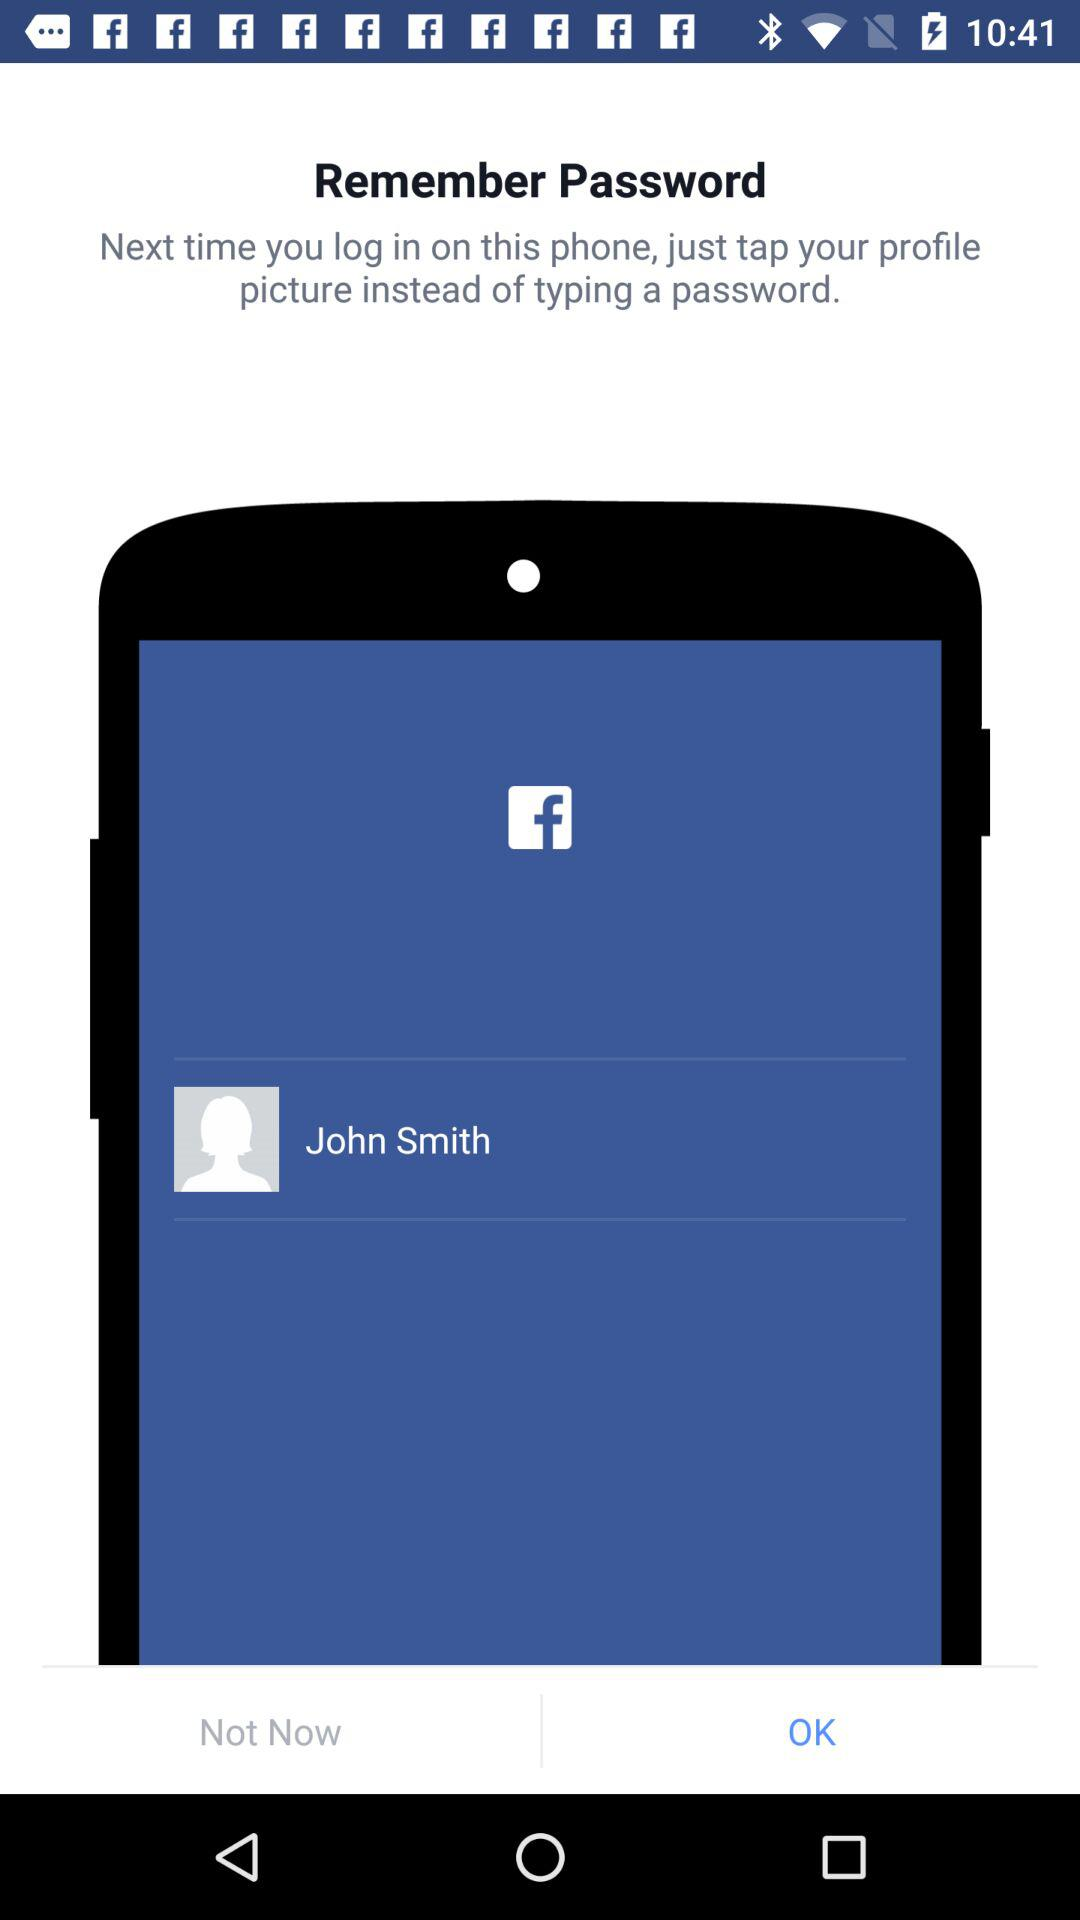What's the user name? The user name is John Smith. 